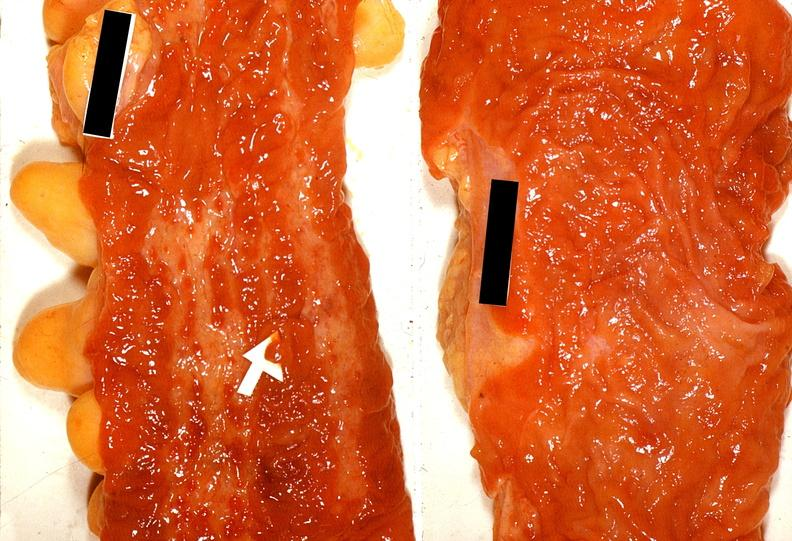what does this image show?
Answer the question using a single word or phrase. Colon 